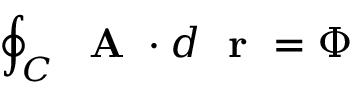<formula> <loc_0><loc_0><loc_500><loc_500>\oint _ { C } A \cdot d r = \Phi</formula> 